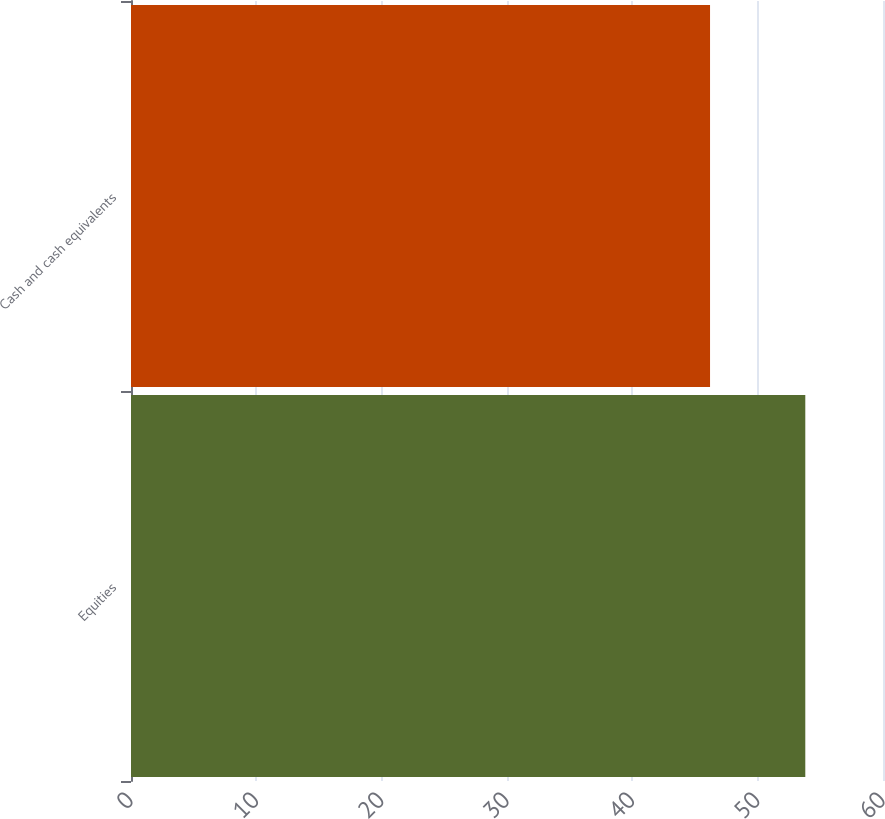Convert chart to OTSL. <chart><loc_0><loc_0><loc_500><loc_500><bar_chart><fcel>Equities<fcel>Cash and cash equivalents<nl><fcel>53.8<fcel>46.2<nl></chart> 